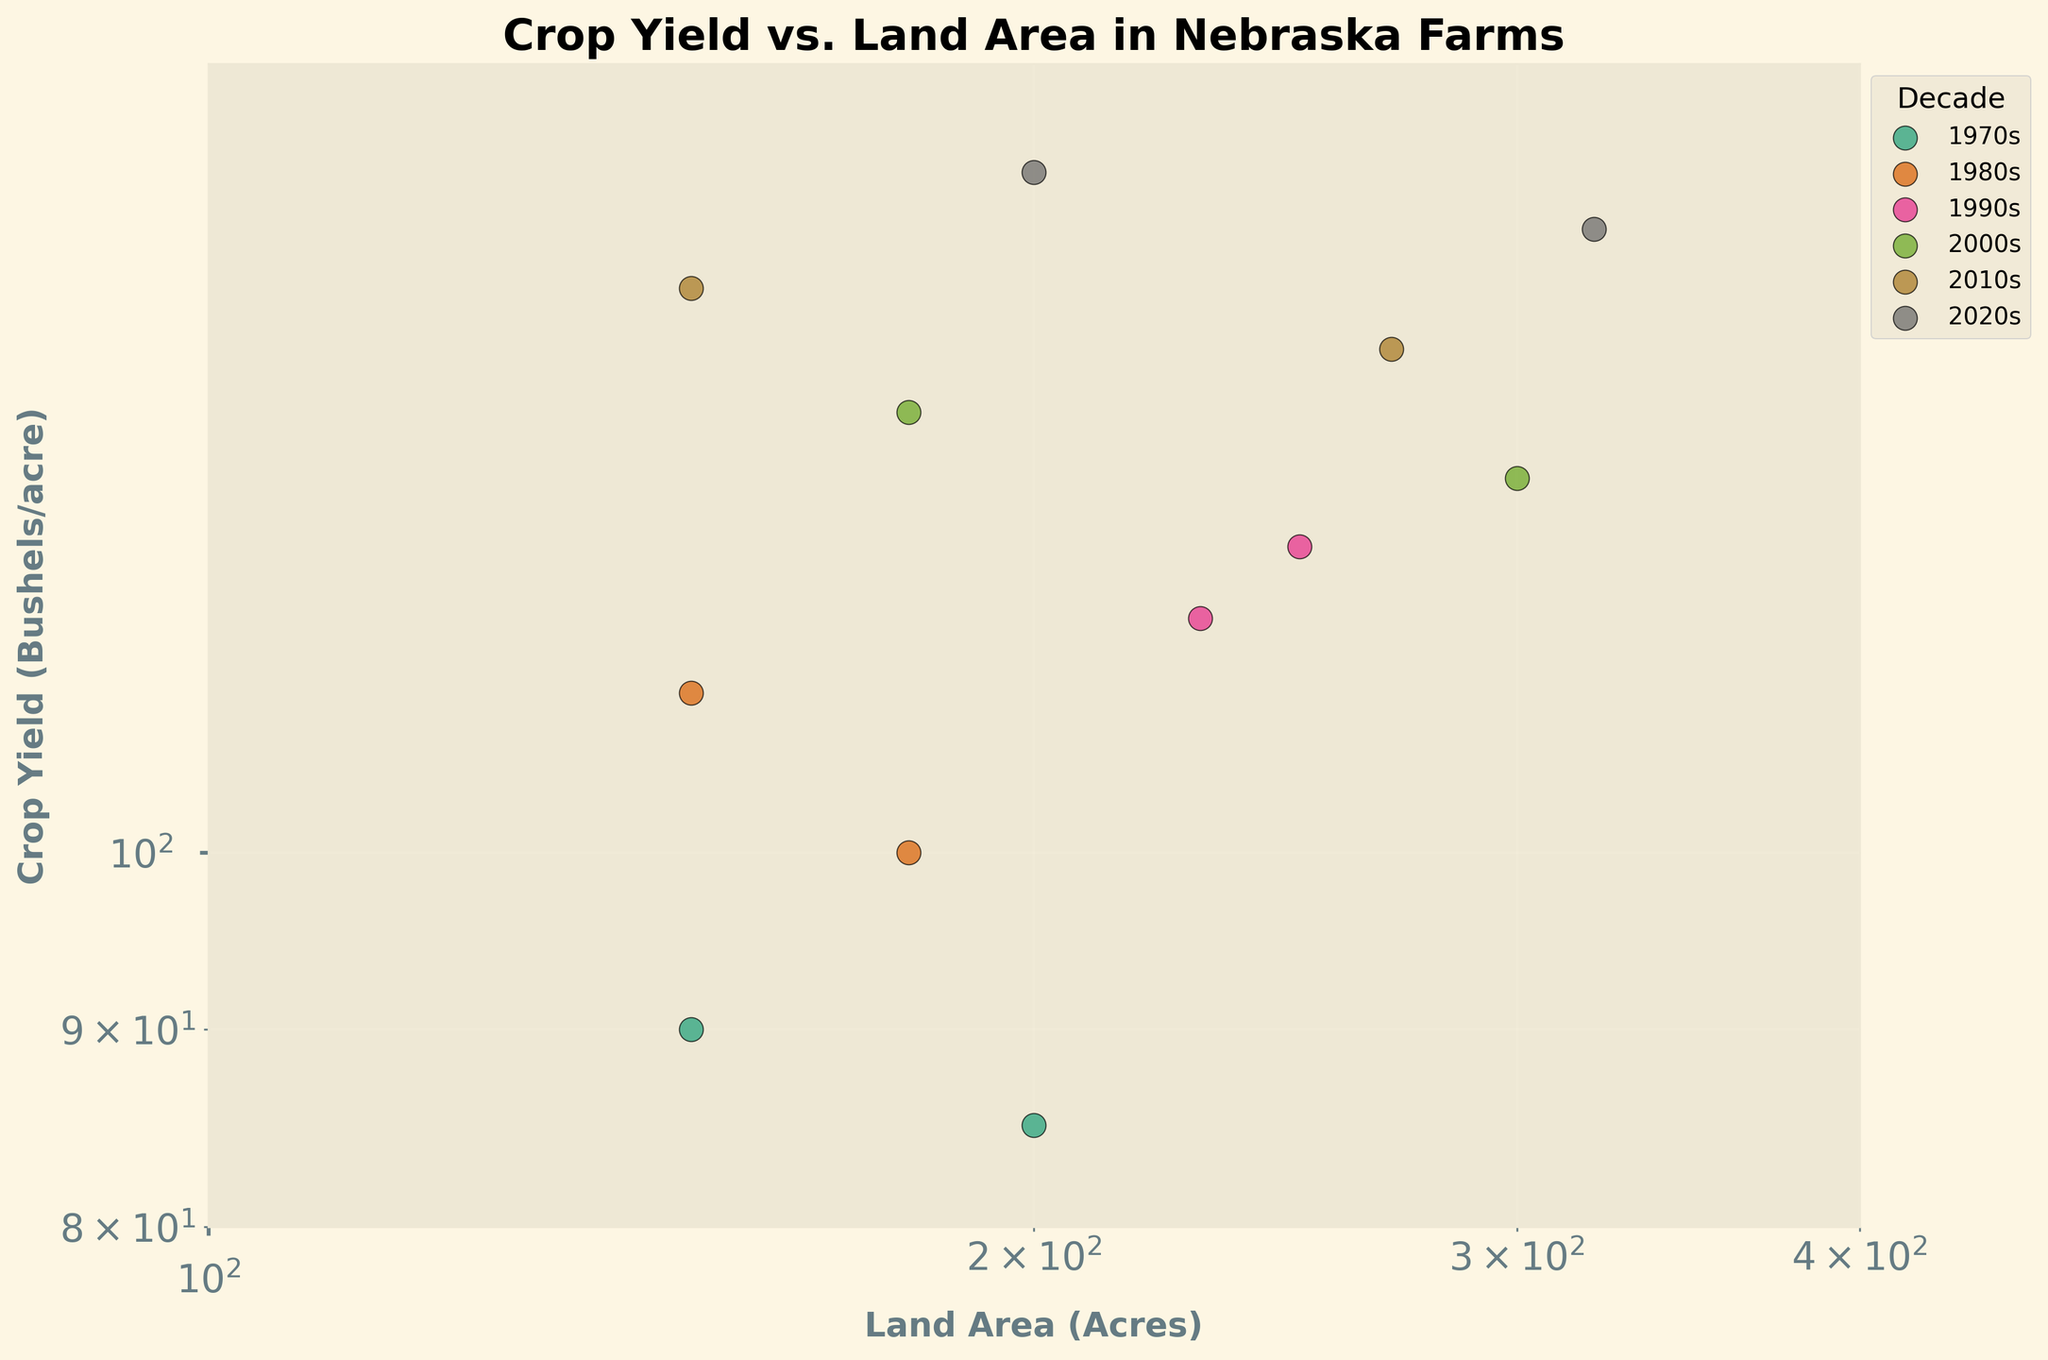How many decades are represented in the figure? The legend shows each decade represented in the plot, which corresponds to the decades displayed in varying colors.
Answer: 6 What is the range of the land areas recorded in the plot? The x-axis has a log scale indicating land areas ranging from approximately 100 to 400 acres.
Answer: 100-400 acres Which decade has the highest crop yield? The scatter plot shows crop yield data for each decade, and the 2020s has the highest yield of 150 bushels/acre.
Answer: 2020s Which farm has the smallest land area in the 2010s? By observing the x-coordinates of the data points color-coded for the 2010s, the SmithFarm has the smallest land area at 150 acres.
Answer: SmithFarm What is the average crop yield for the 2000s decade? In the 2000s, crop yields are 130 and 125 bushels/acre. The average is calculated as (130 + 125) / 2 = 127.5 bushels/acre.
Answer: 127.5 bushels/acre Which farm in the 1990s has a larger land area, DoeFarm or JonesFarm? The x-coordinates indicate that DoeFarm has 250 acres and JonesFarm has 230 acres, so DoeFarm has a larger land area.
Answer: DoeFarm How is the relationship between land area and crop yield represented in the plot? Scatter plots with log scales are used for both axes, demonstrating the logarithmic relationship between land area and crop yield.
Answer: Logarithmic relationship Are there any farms that appear multiple times in different decades? By reviewing the names of the farms’ data points, SmithFarm, JonesFarm, and JohnsonFarm all appear in multiple decades.
Answer: SmithFarm, JonesFarm, JohnsonFarm Which decade has the most variety in land area sizes? Observing the spread of the points, the 2000s exhibit a range from 180 to 300 acres, indicating the most variation among the decades.
Answer: 2000s Is there a correlation between the size of the land area and the crop yield based on the plot? The general trend in the scatter plot indicates a positive correlation: larger land areas often correspond with higher crop yields.
Answer: Positive correlation 